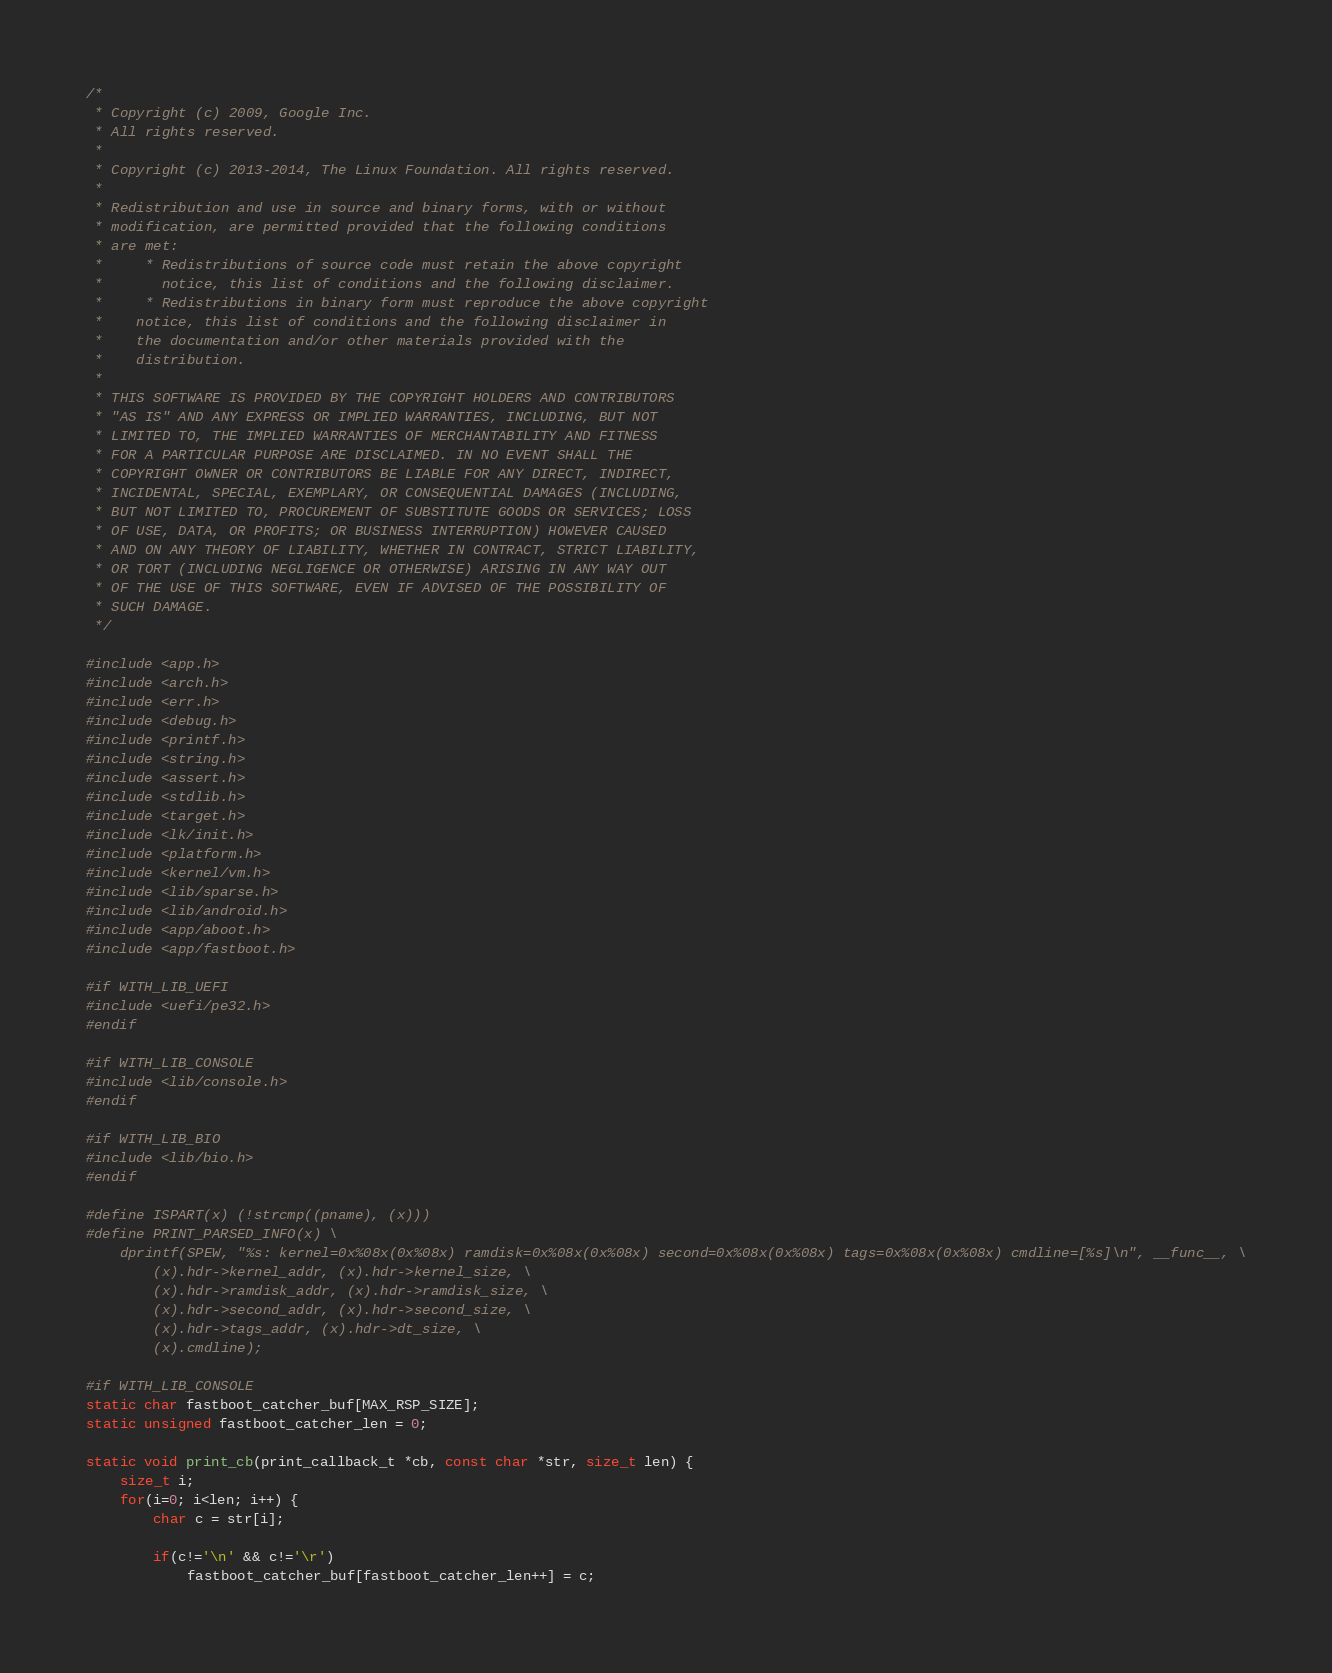Convert code to text. <code><loc_0><loc_0><loc_500><loc_500><_C_>/*
 * Copyright (c) 2009, Google Inc.
 * All rights reserved.
 *
 * Copyright (c) 2013-2014, The Linux Foundation. All rights reserved.
 *
 * Redistribution and use in source and binary forms, with or without
 * modification, are permitted provided that the following conditions
 * are met:
 *     * Redistributions of source code must retain the above copyright
 *       notice, this list of conditions and the following disclaimer.
 *     * Redistributions in binary form must reproduce the above copyright
 *    notice, this list of conditions and the following disclaimer in
 *    the documentation and/or other materials provided with the
 *    distribution.
 *
 * THIS SOFTWARE IS PROVIDED BY THE COPYRIGHT HOLDERS AND CONTRIBUTORS
 * "AS IS" AND ANY EXPRESS OR IMPLIED WARRANTIES, INCLUDING, BUT NOT
 * LIMITED TO, THE IMPLIED WARRANTIES OF MERCHANTABILITY AND FITNESS
 * FOR A PARTICULAR PURPOSE ARE DISCLAIMED. IN NO EVENT SHALL THE
 * COPYRIGHT OWNER OR CONTRIBUTORS BE LIABLE FOR ANY DIRECT, INDIRECT,
 * INCIDENTAL, SPECIAL, EXEMPLARY, OR CONSEQUENTIAL DAMAGES (INCLUDING,
 * BUT NOT LIMITED TO, PROCUREMENT OF SUBSTITUTE GOODS OR SERVICES; LOSS
 * OF USE, DATA, OR PROFITS; OR BUSINESS INTERRUPTION) HOWEVER CAUSED
 * AND ON ANY THEORY OF LIABILITY, WHETHER IN CONTRACT, STRICT LIABILITY,
 * OR TORT (INCLUDING NEGLIGENCE OR OTHERWISE) ARISING IN ANY WAY OUT
 * OF THE USE OF THIS SOFTWARE, EVEN IF ADVISED OF THE POSSIBILITY OF
 * SUCH DAMAGE.
 */

#include <app.h>
#include <arch.h>
#include <err.h>
#include <debug.h>
#include <printf.h>
#include <string.h>
#include <assert.h>
#include <stdlib.h>
#include <target.h>
#include <lk/init.h>
#include <platform.h>
#include <kernel/vm.h>
#include <lib/sparse.h>
#include <lib/android.h>
#include <app/aboot.h>
#include <app/fastboot.h>

#if WITH_LIB_UEFI
#include <uefi/pe32.h>
#endif

#if WITH_LIB_CONSOLE
#include <lib/console.h>
#endif

#if WITH_LIB_BIO
#include <lib/bio.h>
#endif

#define ISPART(x) (!strcmp((pname), (x)))
#define PRINT_PARSED_INFO(x) \
	dprintf(SPEW, "%s: kernel=0x%08x(0x%08x) ramdisk=0x%08x(0x%08x) second=0x%08x(0x%08x) tags=0x%08x(0x%08x) cmdline=[%s]\n", __func__, \
		(x).hdr->kernel_addr, (x).hdr->kernel_size, \
		(x).hdr->ramdisk_addr, (x).hdr->ramdisk_size, \
		(x).hdr->second_addr, (x).hdr->second_size, \
		(x).hdr->tags_addr, (x).hdr->dt_size, \
		(x).cmdline);

#if WITH_LIB_CONSOLE
static char fastboot_catcher_buf[MAX_RSP_SIZE];
static unsigned fastboot_catcher_len = 0;

static void print_cb(print_callback_t *cb, const char *str, size_t len) {
	size_t i;
	for(i=0; i<len; i++) {
		char c = str[i];

		if(c!='\n' && c!='\r')
			fastboot_catcher_buf[fastboot_catcher_len++] = c;
</code> 